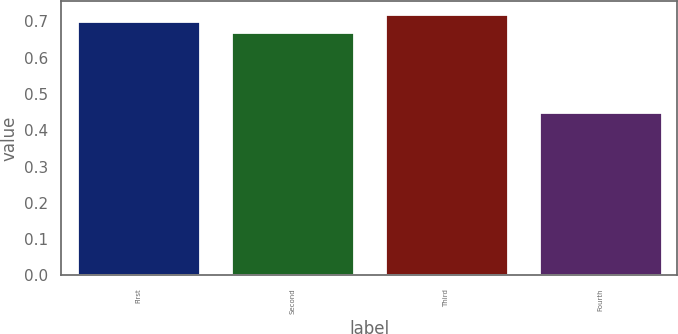Convert chart. <chart><loc_0><loc_0><loc_500><loc_500><bar_chart><fcel>First<fcel>Second<fcel>Third<fcel>Fourth<nl><fcel>0.7<fcel>0.67<fcel>0.72<fcel>0.45<nl></chart> 